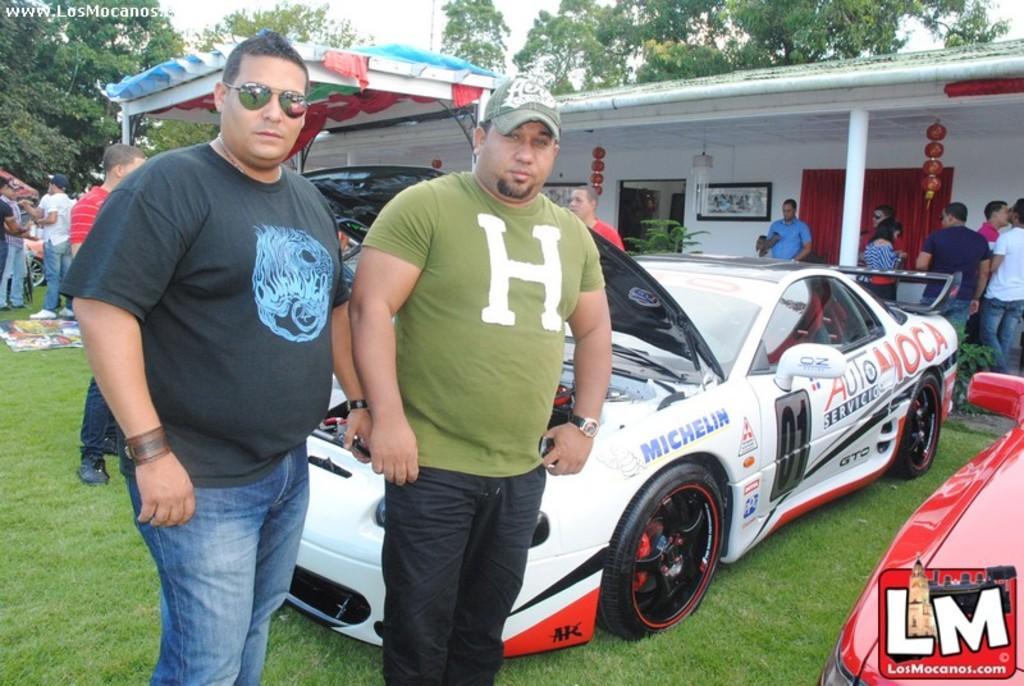In one or two sentences, can you explain what this image depicts? In the picture I can see people are standing on the ground. In the background I can see vehicles, a house, the grass, trees, the sky, a pole, plants and some other objects. On the top left side of the image I can see a watermark. 